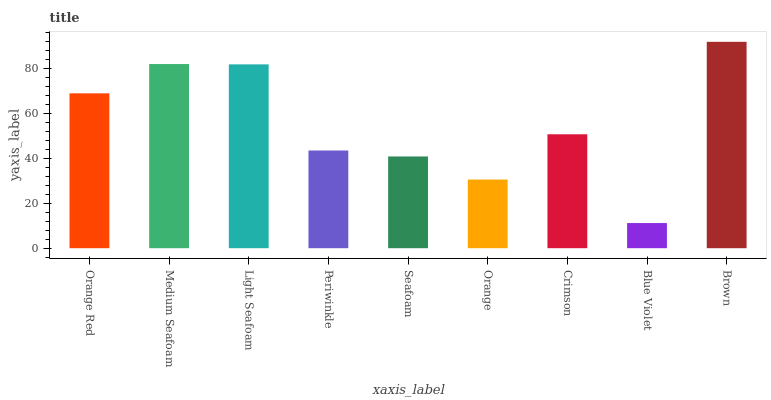Is Blue Violet the minimum?
Answer yes or no. Yes. Is Brown the maximum?
Answer yes or no. Yes. Is Medium Seafoam the minimum?
Answer yes or no. No. Is Medium Seafoam the maximum?
Answer yes or no. No. Is Medium Seafoam greater than Orange Red?
Answer yes or no. Yes. Is Orange Red less than Medium Seafoam?
Answer yes or no. Yes. Is Orange Red greater than Medium Seafoam?
Answer yes or no. No. Is Medium Seafoam less than Orange Red?
Answer yes or no. No. Is Crimson the high median?
Answer yes or no. Yes. Is Crimson the low median?
Answer yes or no. Yes. Is Periwinkle the high median?
Answer yes or no. No. Is Light Seafoam the low median?
Answer yes or no. No. 